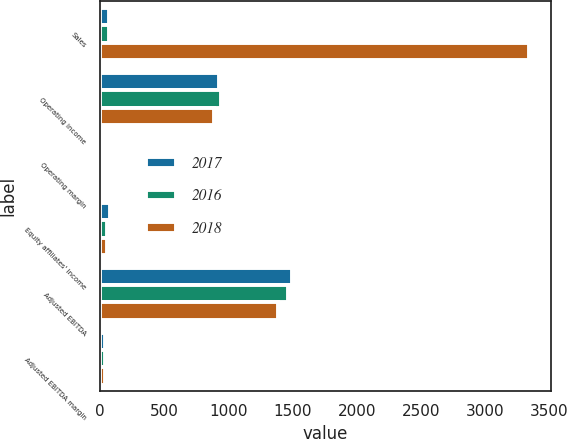Convert chart to OTSL. <chart><loc_0><loc_0><loc_500><loc_500><stacked_bar_chart><ecel><fcel>Sales<fcel>Operating income<fcel>Operating margin<fcel>Equity affiliates' income<fcel>Adjusted EBITDA<fcel>Adjusted EBITDA margin<nl><fcel>2017<fcel>70.05<fcel>927.9<fcel>24.7<fcel>82<fcel>1495.2<fcel>39.8<nl><fcel>2016<fcel>70.05<fcel>946.1<fcel>26<fcel>58.1<fcel>1468.6<fcel>40.4<nl><fcel>2018<fcel>3344.1<fcel>891.3<fcel>26.7<fcel>52.7<fcel>1387.6<fcel>41.5<nl></chart> 